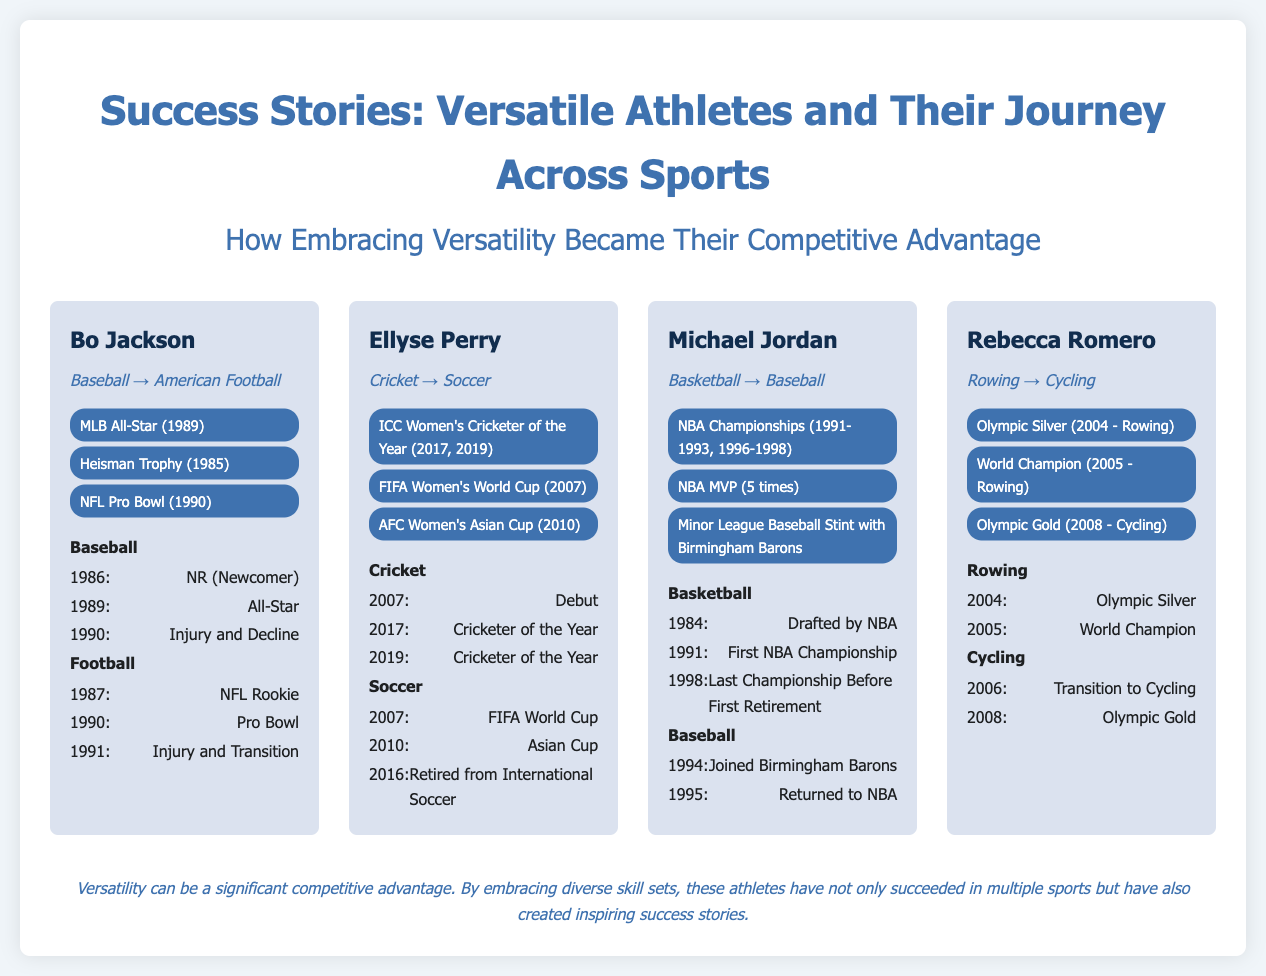What sport did Bo Jackson transition to? Bo Jackson transitioned from Baseball to American Football.
Answer: American Football How many times was Ellyse Perry named ICC Women's Cricketer of the Year? Ellyse Perry was named ICC Women's Cricketer of the Year in 2017 and 2019, which counts as two times.
Answer: 2 times What year did Michael Jordan join the Birmingham Barons? The document states that Michael Jordan joined the Birmingham Barons in 1994.
Answer: 1994 Which athlete won an Olympic Gold in cycling? The athlete who won an Olympic Gold in cycling is Rebecca Romero.
Answer: Rebecca Romero What was the achievement of Bo Jackson in 1989? Bo Jackson was named an MLB All-Star in 1989.
Answer: MLB All-Star In which year did Ellyse Perry retire from international soccer? Ellyse Perry retired from international soccer in 2016.
Answer: 2016 How many NBA Championships did Michael Jordan win? Michael Jordan won a total of 6 NBA Championships from 1991 to 1998.
Answer: 6 Championships What does the footer suggest about versatility? The footer mentions that versatility can be a significant competitive advantage.
Answer: Significant competitive advantage 